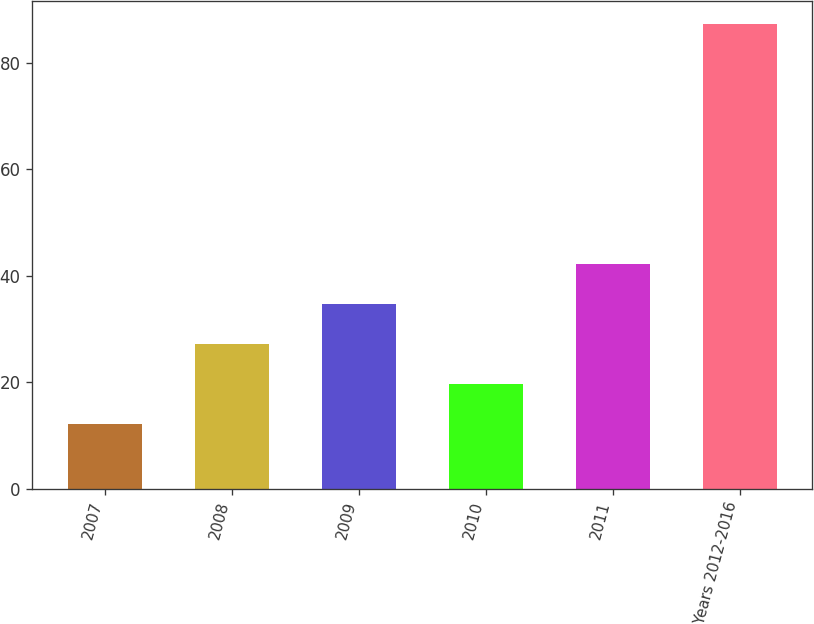<chart> <loc_0><loc_0><loc_500><loc_500><bar_chart><fcel>2007<fcel>2008<fcel>2009<fcel>2010<fcel>2011<fcel>Years 2012-2016<nl><fcel>12.2<fcel>27.2<fcel>34.7<fcel>19.7<fcel>42.2<fcel>87.2<nl></chart> 